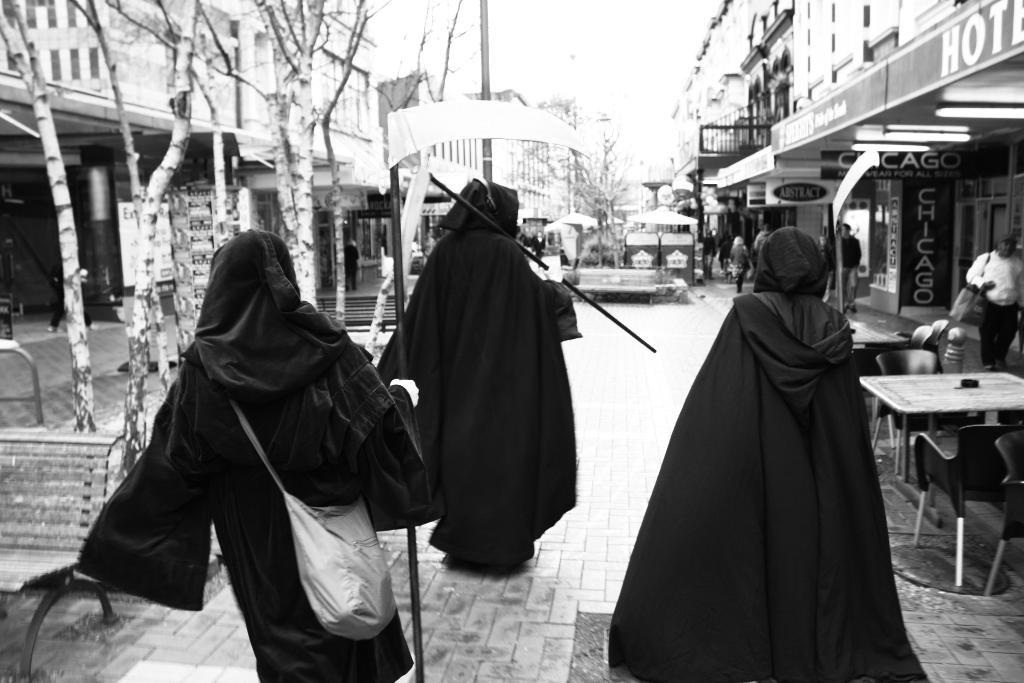How many people are walking on the pavement in the image? There are 3 people walking on the pavement in the image. What furniture is visible near the people? There are chairs and a table nearby. What type of establishments can be seen on the right side of the image? There are shops on the right side of the image. What natural element is present in the image? There is a tree in the image. Where is the girl sitting by the harbor in the image? There is no girl sitting by the harbor in the image; the image only features 3 people walking on the pavement, chairs, a table, shops, and a tree. 